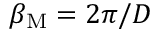Convert formula to latex. <formula><loc_0><loc_0><loc_500><loc_500>\beta _ { M } = 2 \pi / D</formula> 